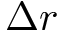Convert formula to latex. <formula><loc_0><loc_0><loc_500><loc_500>\Delta r</formula> 